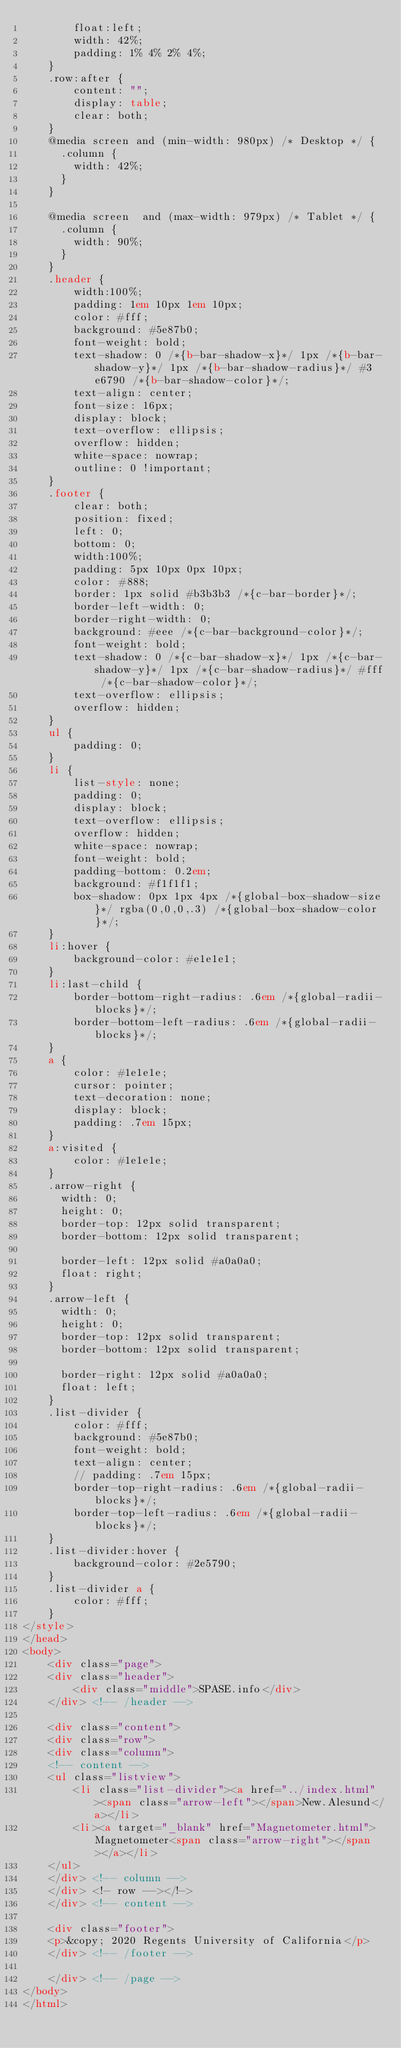<code> <loc_0><loc_0><loc_500><loc_500><_HTML_>		float:left;
		width: 42%;
		padding: 1% 4% 2% 4%;
	}
	.row:after {
		content: "";
		display: table;
		clear: both;
	}	
	@media screen and (min-width: 980px) /* Desktop */ {
	  .column {
		width: 42%;
	  }
	}

	@media screen  and (max-width: 979px) /* Tablet */ {
	  .column {
		width: 90%;
	  }
	}
	.header {
		width:100%;
		padding: 1em 10px 1em 10px;
		color: #fff;
		background: #5e87b0;
		font-weight: bold;
		text-shadow: 0 /*{b-bar-shadow-x}*/ 1px /*{b-bar-shadow-y}*/ 1px /*{b-bar-shadow-radius}*/ #3e6790 /*{b-bar-shadow-color}*/;
		text-align: center;
		font-size: 16px;
		display: block;
		text-overflow: ellipsis;
		overflow: hidden;
		white-space: nowrap;
		outline: 0 !important;
	}
	.footer {
		clear: both;
		position: fixed;
		left: 0;
		bottom: 0;
		width:100%;
		padding: 5px 10px 0px 10px;
		color: #888;
		border: 1px solid #b3b3b3 /*{c-bar-border}*/;
		border-left-width: 0;
		border-right-width: 0;
		background: #eee /*{c-bar-background-color}*/;
		font-weight: bold;
		text-shadow: 0 /*{c-bar-shadow-x}*/ 1px /*{c-bar-shadow-y}*/ 1px /*{c-bar-shadow-radius}*/ #fff /*{c-bar-shadow-color}*/;
		text-overflow: ellipsis;
		overflow: hidden;
	}
	ul {
		padding: 0;
	}
	li {
		list-style: none;
		padding: 0;
		display: block;
	    text-overflow: ellipsis;
		overflow: hidden;
		white-space: nowrap;
		font-weight: bold;
		padding-bottom: 0.2em;
		background: #f1f1f1;
		box-shadow: 0px 1px 4px /*{global-box-shadow-size}*/ rgba(0,0,0,.3) /*{global-box-shadow-color}*/;
	}
	li:hover {
		background-color: #e1e1e1;
	}
	li:last-child {
		border-bottom-right-radius: .6em /*{global-radii-blocks}*/;
		border-bottom-left-radius: .6em /*{global-radii-blocks}*/;
	}
	a {
		color: #1e1e1e;
		cursor: pointer;
		text-decoration: none;
		display: block;
		padding: .7em 15px;
	}
	a:visited {
		color: #1e1e1e;
	}
	.arrow-right {
	  width: 0; 
	  height: 0; 
	  border-top: 12px solid transparent;
	  border-bottom: 12px solid transparent;
	  
	  border-left: 12px solid #a0a0a0;
	  float: right;
	}
	.arrow-left {
	  width: 0; 
	  height: 0; 
	  border-top: 12px solid transparent;
	  border-bottom: 12px solid transparent;
	  
	  border-right: 12px solid #a0a0a0;
	  float: left;
	}
	.list-divider {
		color: #fff;
		background: #5e87b0;
		font-weight: bold;
		text-align: center;
		// padding: .7em 15px;
		border-top-right-radius: .6em /*{global-radii-blocks}*/;
		border-top-left-radius: .6em /*{global-radii-blocks}*/;
	}
	.list-divider:hover {
		background-color: #2e5790;
	}
	.list-divider a {
		color: #fff;
	}
</style>
</head>
<body>
	<div class="page">
	<div class="header">
		<div class="middle">SPASE.info</div>
	</div> <!-- /header -->
	
	<div class="content">
	<div class="row">
	<div class="column">
	<!-- content -->
	<ul class="listview">
		<li class="list-divider"><a href="../index.html"><span class="arrow-left"></span>New.Alesund</a></li>
		<li><a target="_blank" href="Magnetometer.html">Magnetometer<span class="arrow-right"></span></a></li>
	</ul>
	</div> <!-- column -->
	</div> <!- row --></!->
	</div> <!-- content -->
	
	<div class="footer">
	<p>&copy; 2020 Regents University of California</p>
	</div> <!-- /footer -->
	
	</div> <!-- /page -->
</body>
</html></code> 